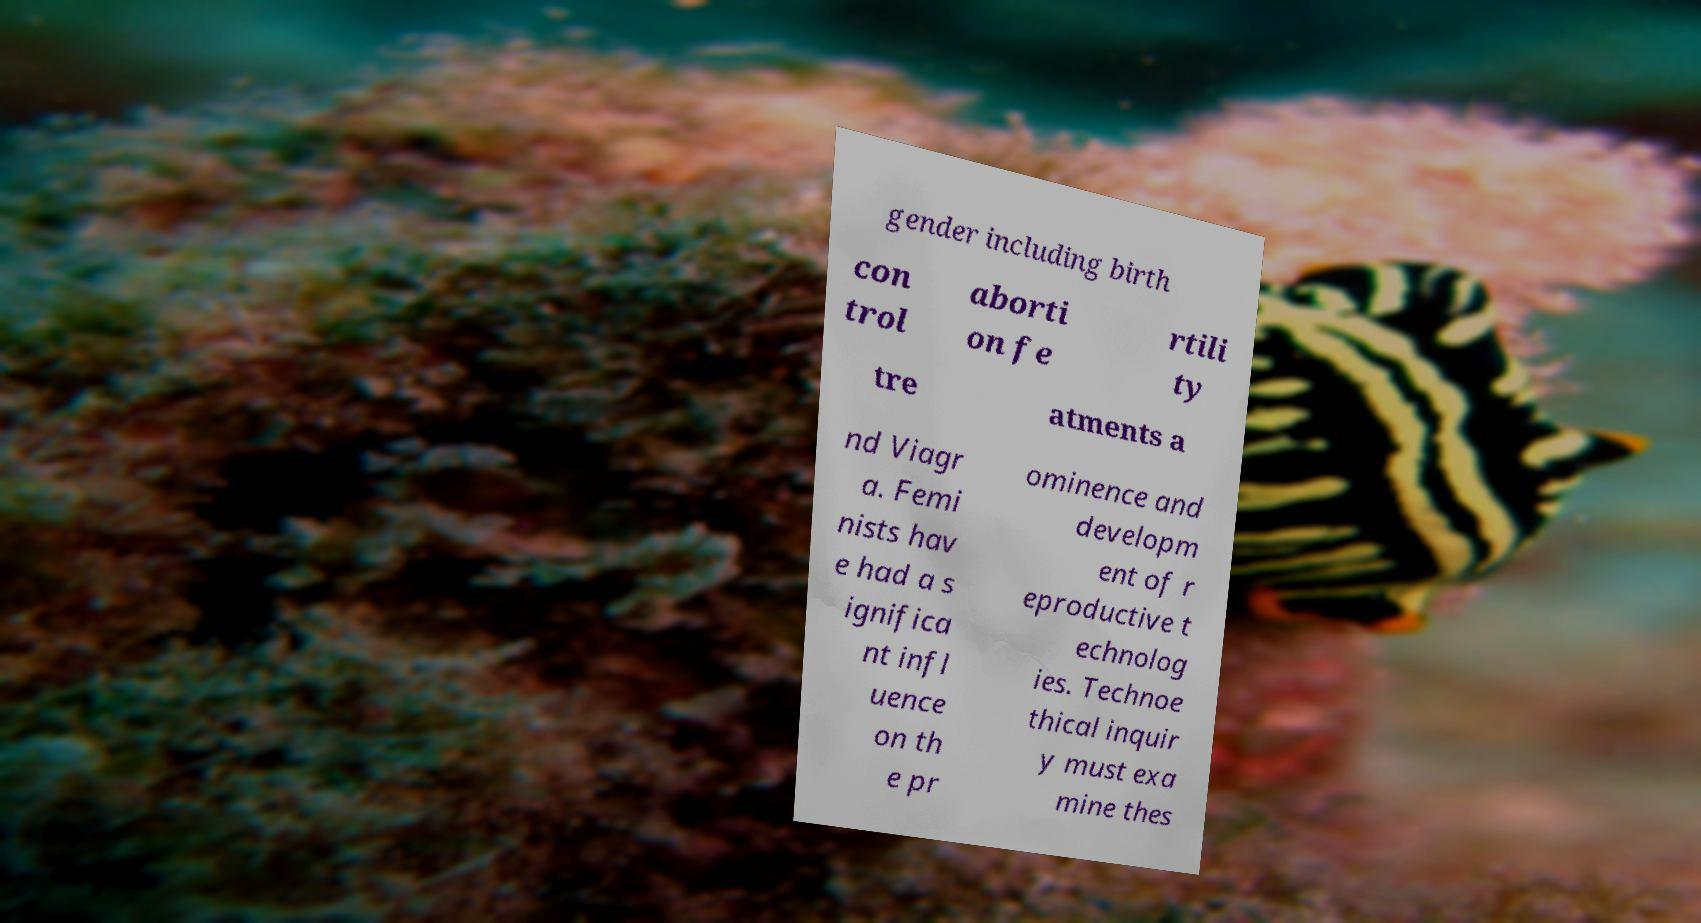For documentation purposes, I need the text within this image transcribed. Could you provide that? gender including birth con trol aborti on fe rtili ty tre atments a nd Viagr a. Femi nists hav e had a s ignifica nt infl uence on th e pr ominence and developm ent of r eproductive t echnolog ies. Technoe thical inquir y must exa mine thes 